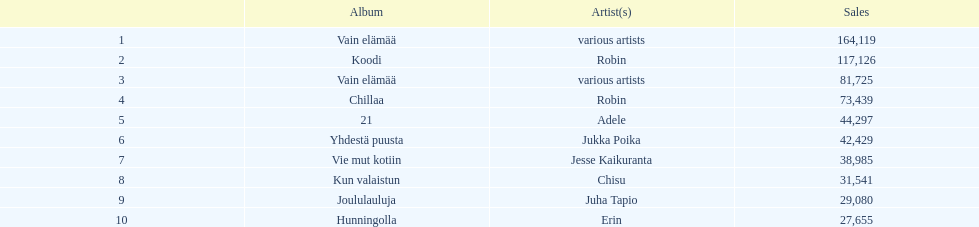Which was better selling, hunningolla or vain elamaa? Vain elämää. 